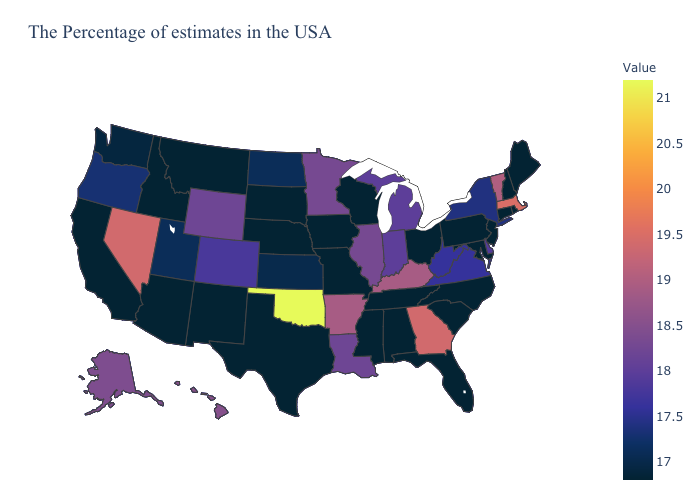Among the states that border Nevada , which have the highest value?
Concise answer only. Oregon. Which states have the lowest value in the USA?
Short answer required. Maine, Rhode Island, New Hampshire, Connecticut, New Jersey, Maryland, Pennsylvania, North Carolina, South Carolina, Ohio, Florida, Alabama, Tennessee, Wisconsin, Mississippi, Missouri, Iowa, Nebraska, Texas, South Dakota, New Mexico, Montana, Arizona, Idaho, California. Does Massachusetts have the lowest value in the USA?
Answer briefly. No. Does Alabama have the highest value in the USA?
Quick response, please. No. 